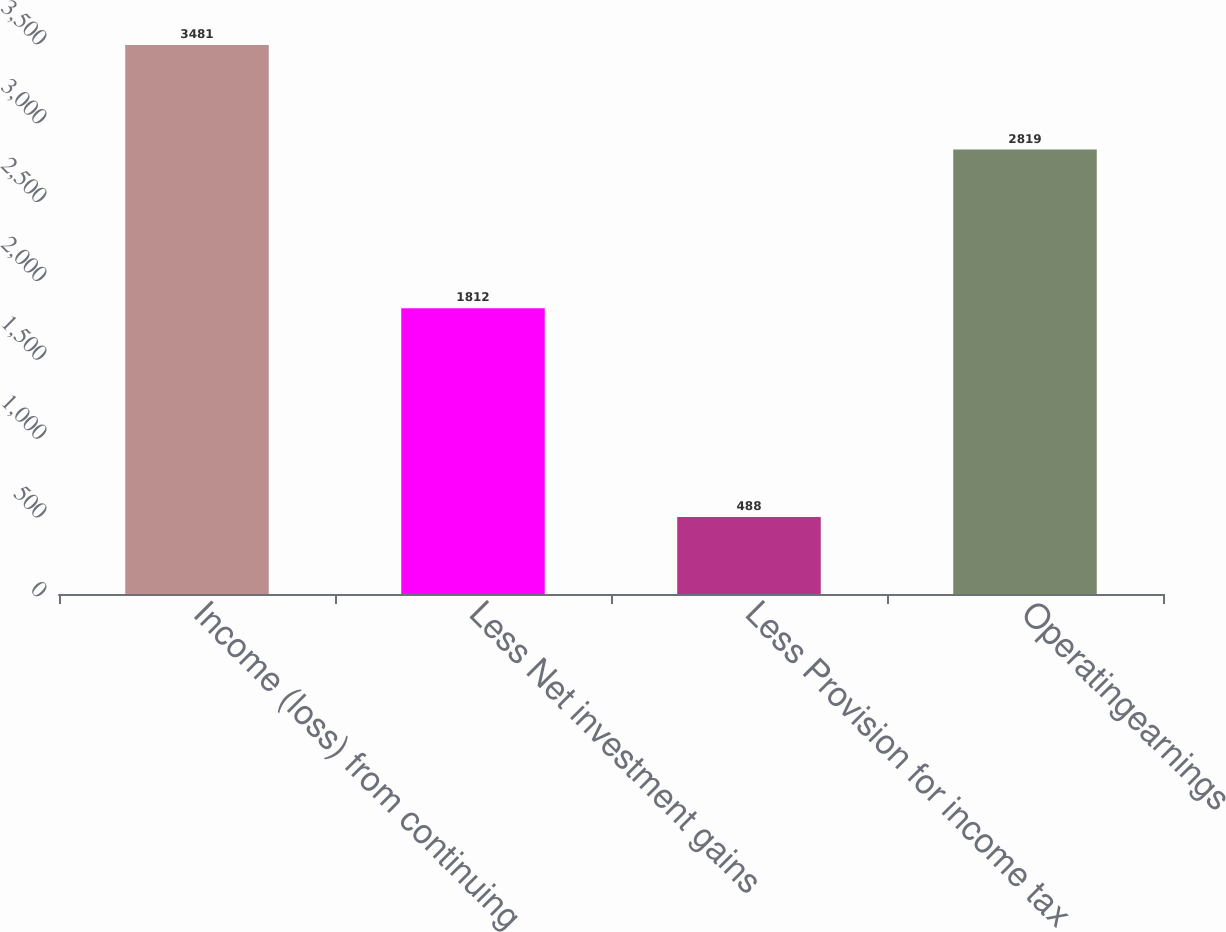<chart> <loc_0><loc_0><loc_500><loc_500><bar_chart><fcel>Income (loss) from continuing<fcel>Less Net investment gains<fcel>Less Provision for income tax<fcel>Operatingearnings<nl><fcel>3481<fcel>1812<fcel>488<fcel>2819<nl></chart> 